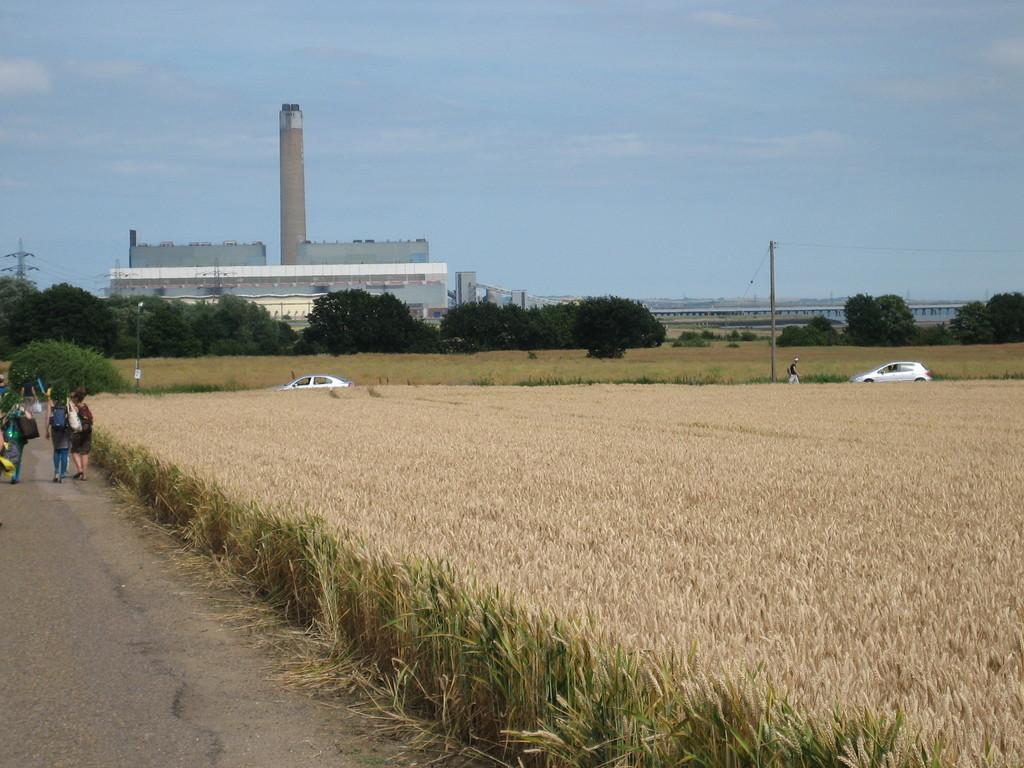How would you summarize this image in a sentence or two? In the background we can see the sky, building, tower. In this picture we can see the poles, transmission wires, trees, fields, vehicles, road, objects and the people. 